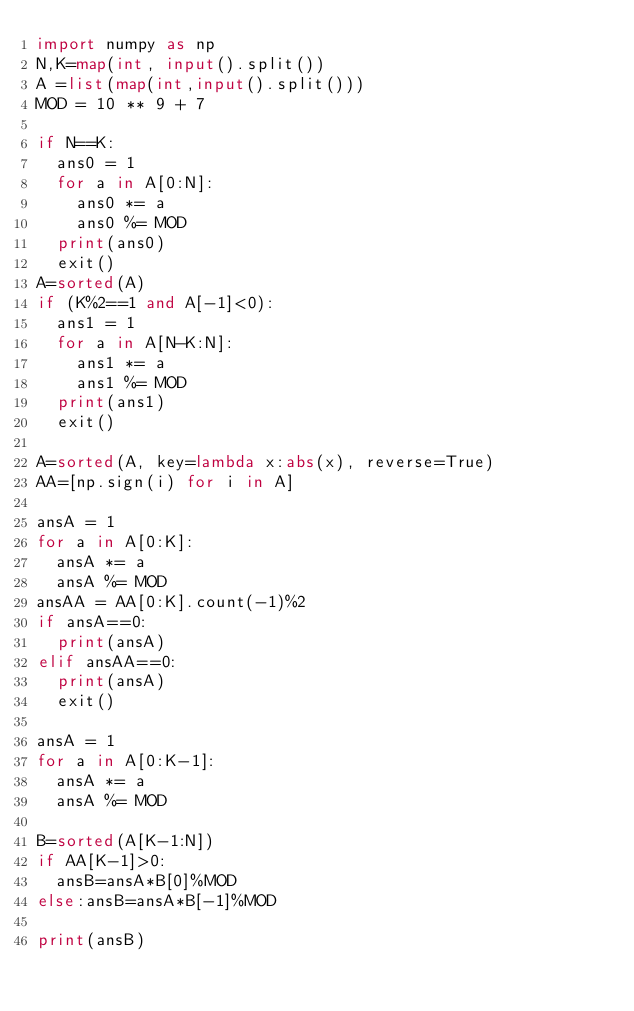<code> <loc_0><loc_0><loc_500><loc_500><_Python_>import numpy as np
N,K=map(int, input().split())
A =list(map(int,input().split()))
MOD = 10 ** 9 + 7

if N==K:
  ans0 = 1
  for a in A[0:N]:
    ans0 *= a
    ans0 %= MOD
  print(ans0)
  exit()
A=sorted(A)  
if (K%2==1 and A[-1]<0):
  ans1 = 1
  for a in A[N-K:N]:
    ans1 *= a
    ans1 %= MOD
  print(ans1)
  exit()

A=sorted(A, key=lambda x:abs(x), reverse=True)
AA=[np.sign(i) for i in A]

ansA = 1
for a in A[0:K]:
  ansA *= a
  ansA %= MOD
ansAA = AA[0:K].count(-1)%2
if ansA==0:
  print(ansA)
elif ansAA==0:
  print(ansA)
  exit()
  
ansA = 1
for a in A[0:K-1]:
  ansA *= a
  ansA %= MOD  

B=sorted(A[K-1:N])
if AA[K-1]>0:
  ansB=ansA*B[0]%MOD
else:ansB=ansA*B[-1]%MOD

print(ansB)</code> 